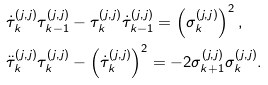Convert formula to latex. <formula><loc_0><loc_0><loc_500><loc_500>& \dot { \tau } _ { k } ^ { ( j , j ) } \tau _ { k - 1 } ^ { ( j , j ) } - \tau _ { k } ^ { ( j , j ) } \dot { \tau } _ { k - 1 } ^ { ( j , j ) } = \left ( \sigma _ { k } ^ { ( j , j ) } \right ) ^ { 2 } , \\ & \ddot { \tau } _ { k } ^ { ( j , j ) } \tau _ { k } ^ { ( j , j ) } - \left ( \dot { \tau } _ { k } ^ { ( j , j ) } \right ) ^ { 2 } = - 2 \sigma _ { k + 1 } ^ { ( j , j ) } \sigma _ { k } ^ { ( j , j ) } .</formula> 